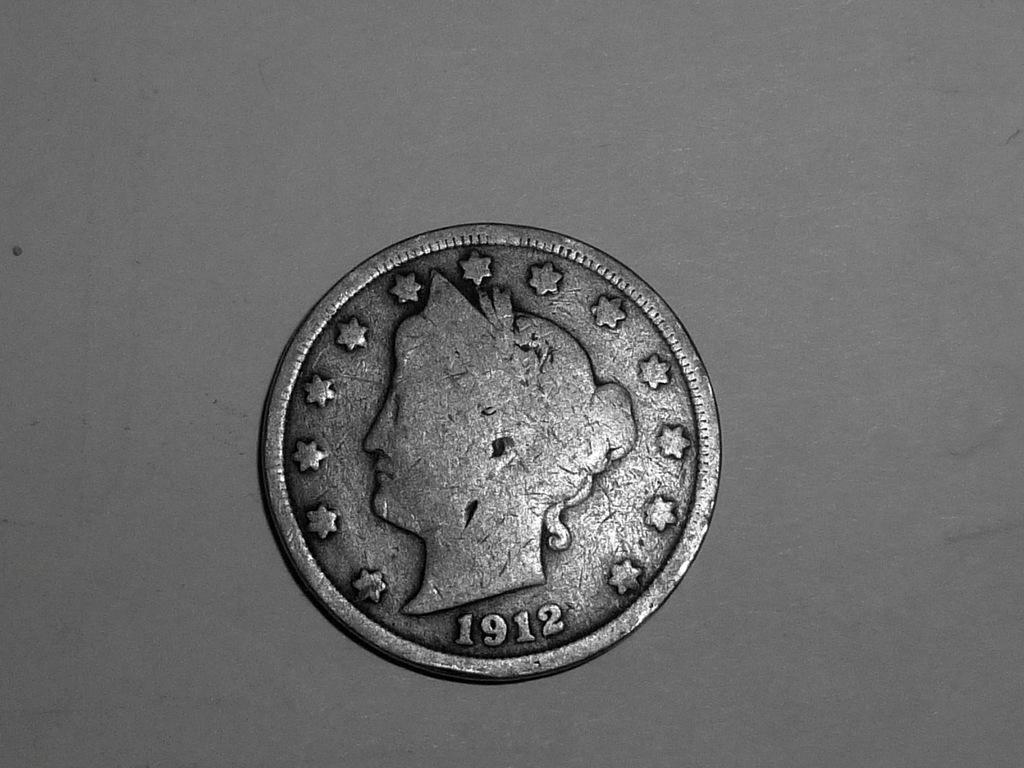<image>
Share a concise interpretation of the image provided. A silver coin featuring a woman's head and a 1912 inscription. 